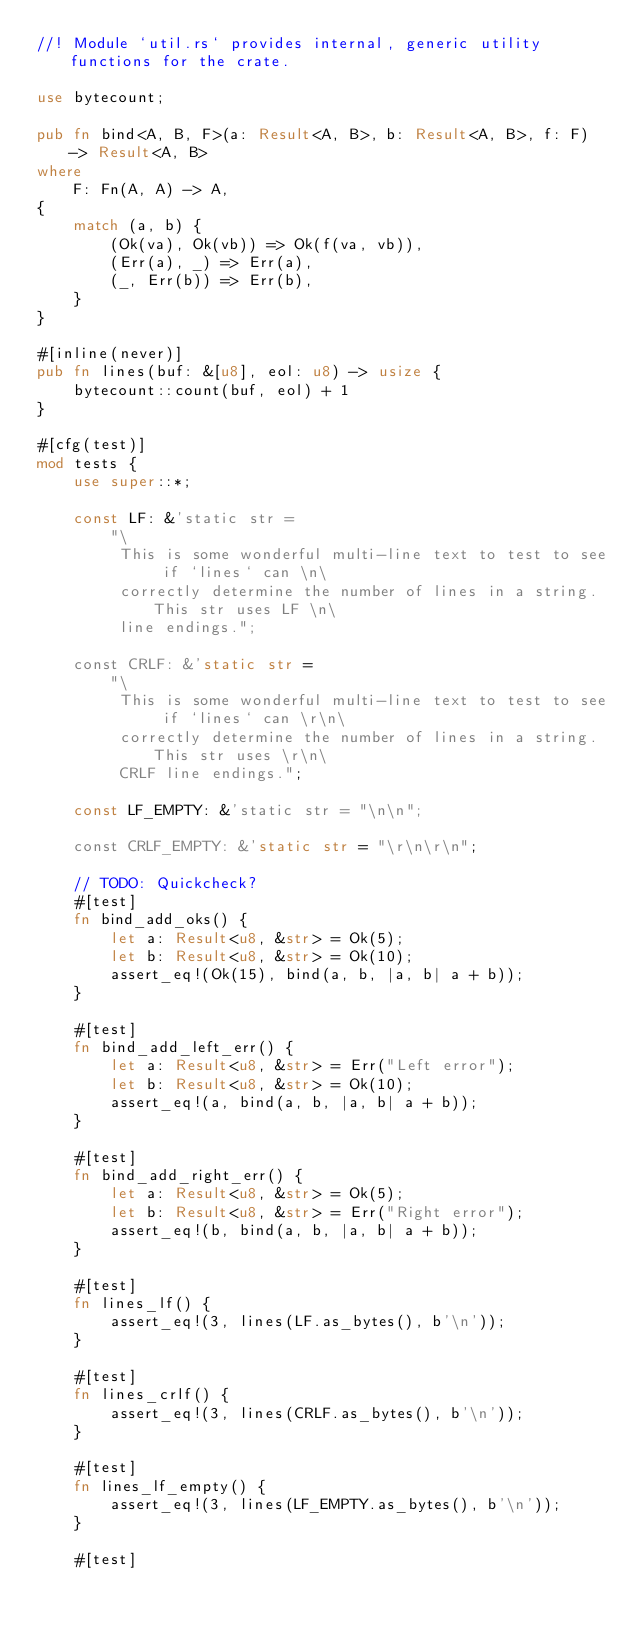<code> <loc_0><loc_0><loc_500><loc_500><_Rust_>//! Module `util.rs` provides internal, generic utility functions for the crate.

use bytecount;

pub fn bind<A, B, F>(a: Result<A, B>, b: Result<A, B>, f: F) -> Result<A, B>
where
    F: Fn(A, A) -> A,
{
    match (a, b) {
        (Ok(va), Ok(vb)) => Ok(f(va, vb)),
        (Err(a), _) => Err(a),
        (_, Err(b)) => Err(b),
    }
}

#[inline(never)]
pub fn lines(buf: &[u8], eol: u8) -> usize {
    bytecount::count(buf, eol) + 1
}

#[cfg(test)]
mod tests {
    use super::*;

    const LF: &'static str =
        "\
         This is some wonderful multi-line text to test to see if `lines` can \n\
         correctly determine the number of lines in a string. This str uses LF \n\
         line endings.";

    const CRLF: &'static str =
        "\
         This is some wonderful multi-line text to test to see if `lines` can \r\n\
         correctly determine the number of lines in a string. This str uses \r\n\
         CRLF line endings.";

    const LF_EMPTY: &'static str = "\n\n";

    const CRLF_EMPTY: &'static str = "\r\n\r\n";

    // TODO: Quickcheck?
    #[test]
    fn bind_add_oks() {
        let a: Result<u8, &str> = Ok(5);
        let b: Result<u8, &str> = Ok(10);
        assert_eq!(Ok(15), bind(a, b, |a, b| a + b));
    }

    #[test]
    fn bind_add_left_err() {
        let a: Result<u8, &str> = Err("Left error");
        let b: Result<u8, &str> = Ok(10);
        assert_eq!(a, bind(a, b, |a, b| a + b));
    }

    #[test]
    fn bind_add_right_err() {
        let a: Result<u8, &str> = Ok(5);
        let b: Result<u8, &str> = Err("Right error");
        assert_eq!(b, bind(a, b, |a, b| a + b));
    }

    #[test]
    fn lines_lf() {
        assert_eq!(3, lines(LF.as_bytes(), b'\n'));
    }

    #[test]
    fn lines_crlf() {
        assert_eq!(3, lines(CRLF.as_bytes(), b'\n'));
    }

    #[test]
    fn lines_lf_empty() {
        assert_eq!(3, lines(LF_EMPTY.as_bytes(), b'\n'));
    }

    #[test]</code> 